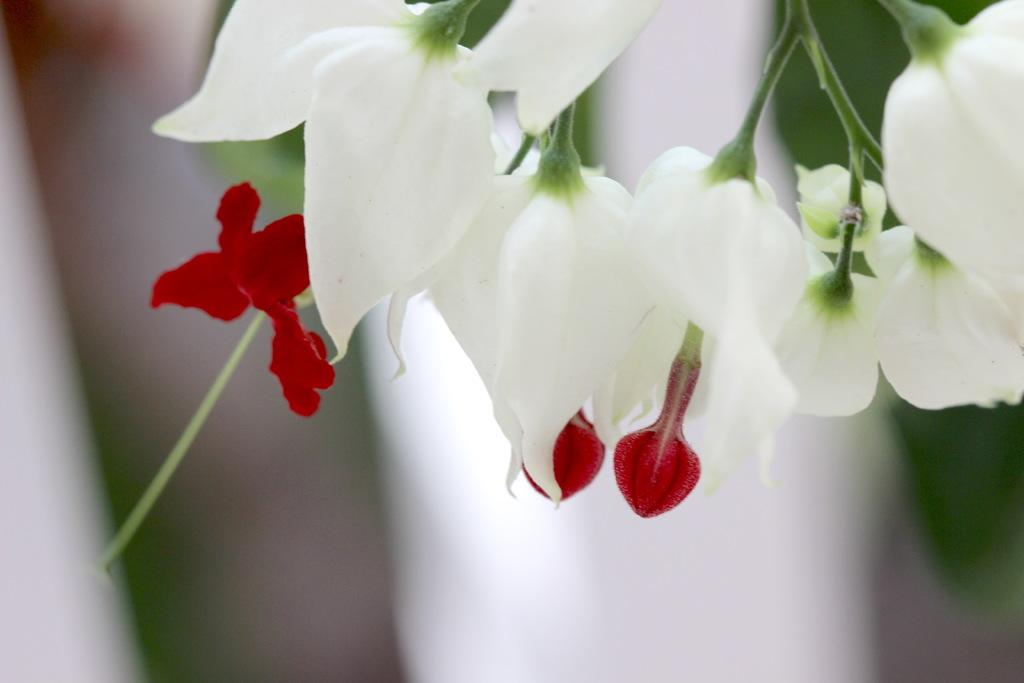What is present in the image? There are flowers in the image. Can you describe the background of the image? The background of the image is blurry. How many wings can be seen on the flowers in the image? There are no wings present on the flowers in the image. What type of noise can be heard coming from the horses in the image? There are no horses present in the image, so no noise can be heard from them. 